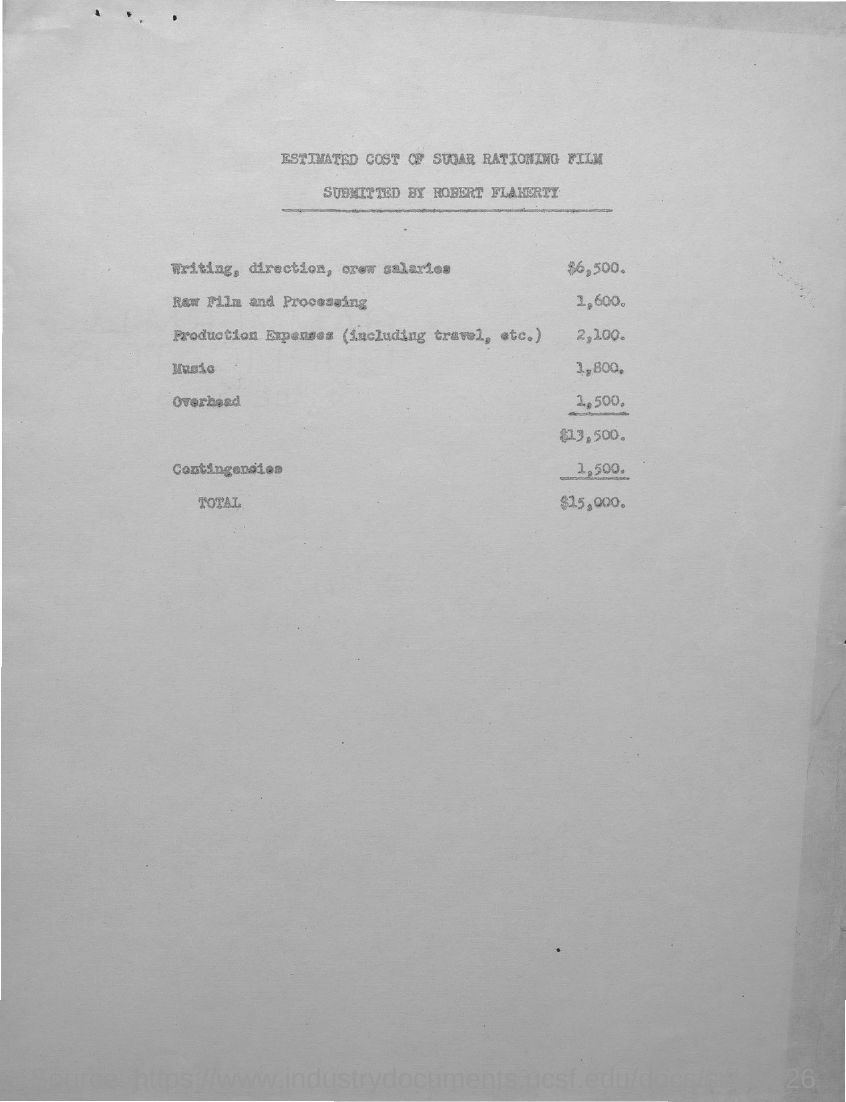What is the Total?
Your response must be concise. 15,000. 